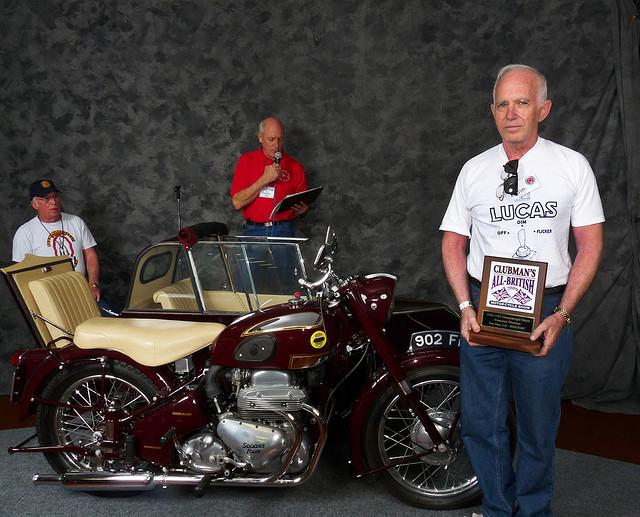Why is the man holding a microphone?

Choices:
A) he's yelling
B) he's singing
C) he's crying
D) he's speaking he's speaking 